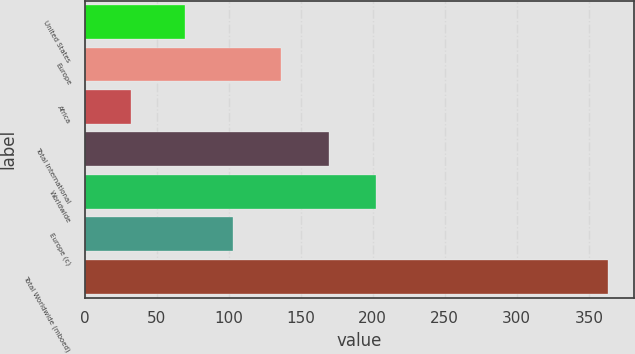Convert chart to OTSL. <chart><loc_0><loc_0><loc_500><loc_500><bar_chart><fcel>United States<fcel>Europe<fcel>Africa<fcel>Total International<fcel>Worldwide<fcel>Europe (c)<fcel>Total Worldwide (mboed)<nl><fcel>70<fcel>136.2<fcel>32<fcel>169.3<fcel>202.4<fcel>103.1<fcel>363<nl></chart> 